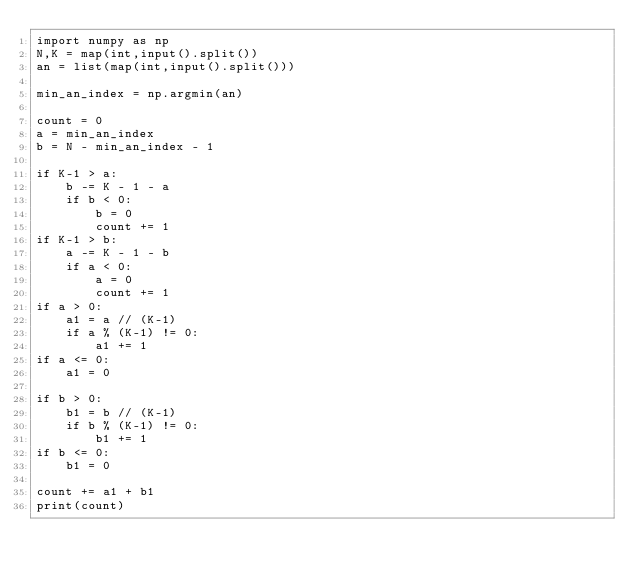Convert code to text. <code><loc_0><loc_0><loc_500><loc_500><_Python_>import numpy as np
N,K = map(int,input().split())
an = list(map(int,input().split()))

min_an_index = np.argmin(an)

count = 0
a = min_an_index
b = N - min_an_index - 1

if K-1 > a:
    b -= K - 1 - a
    if b < 0:
        b = 0
        count += 1
if K-1 > b:
    a -= K - 1 - b
    if a < 0:
        a = 0
        count += 1
if a > 0:        
    a1 = a // (K-1)
    if a % (K-1) != 0:
        a1 += 1
if a <= 0:
    a1 = 0
    
if b > 0:    
    b1 = b // (K-1)
    if b % (K-1) != 0:
        b1 += 1
if b <= 0:
    b1 = 0

count += a1 + b1
print(count)</code> 